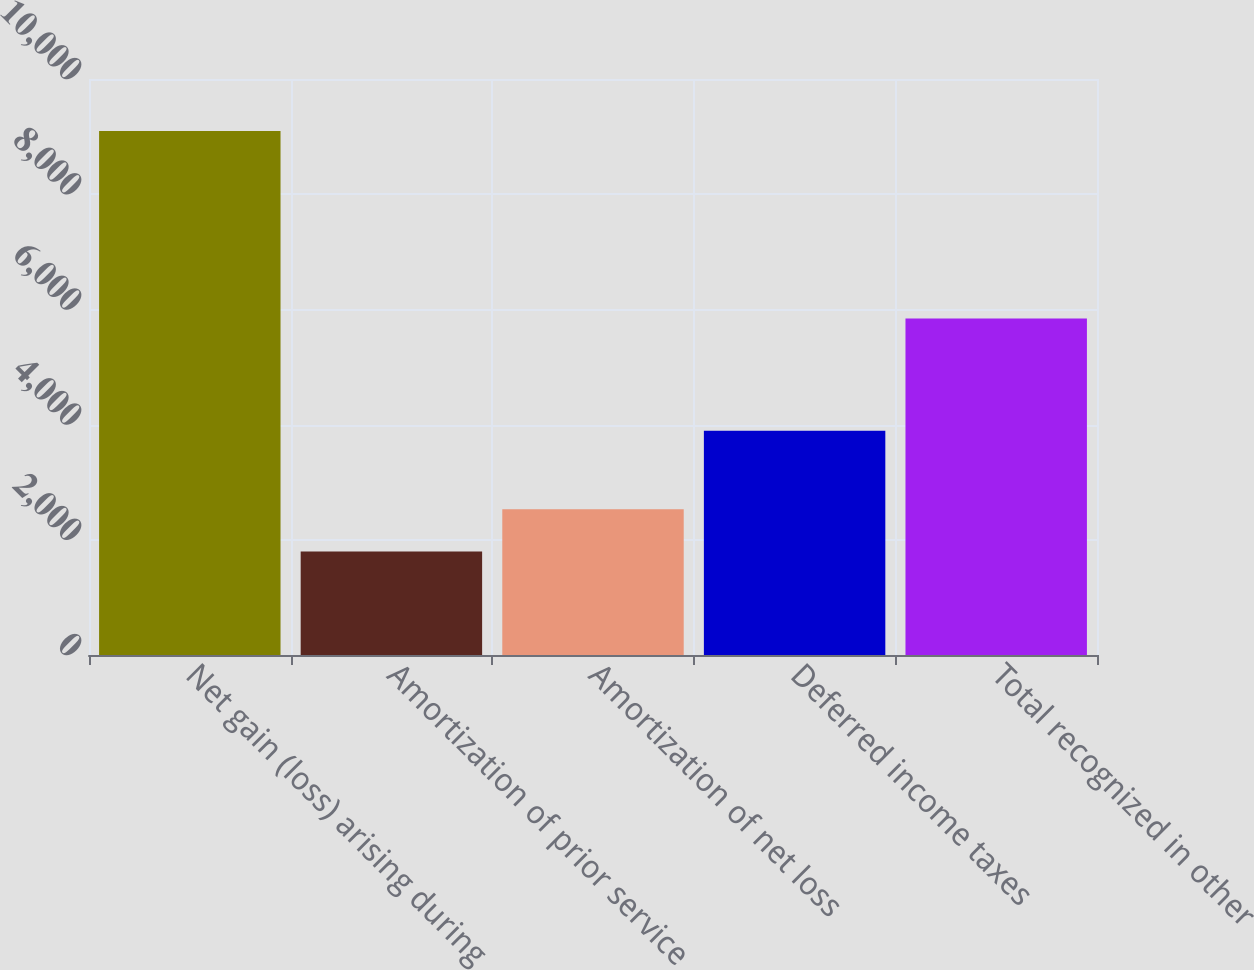<chart> <loc_0><loc_0><loc_500><loc_500><bar_chart><fcel>Net gain (loss) arising during<fcel>Amortization of prior service<fcel>Amortization of net loss<fcel>Deferred income taxes<fcel>Total recognized in other<nl><fcel>9096<fcel>1799<fcel>2528.7<fcel>3895<fcel>5842<nl></chart> 